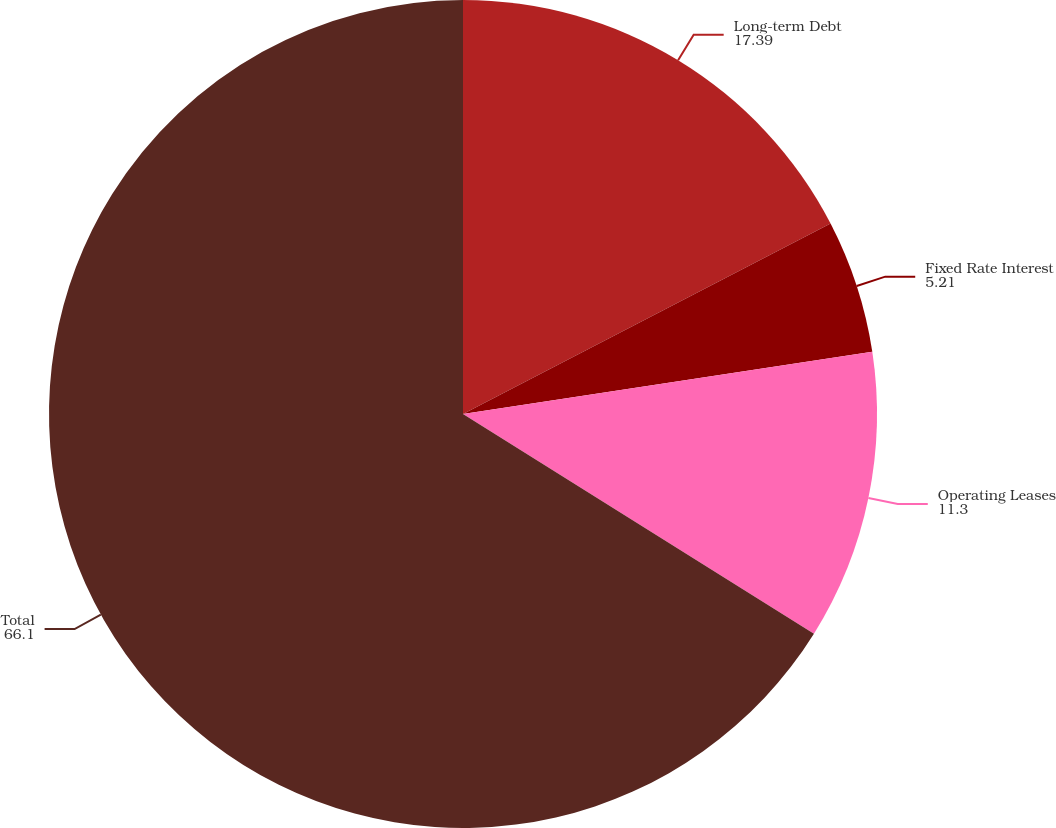<chart> <loc_0><loc_0><loc_500><loc_500><pie_chart><fcel>Long-term Debt<fcel>Fixed Rate Interest<fcel>Operating Leases<fcel>Total<nl><fcel>17.39%<fcel>5.21%<fcel>11.3%<fcel>66.1%<nl></chart> 